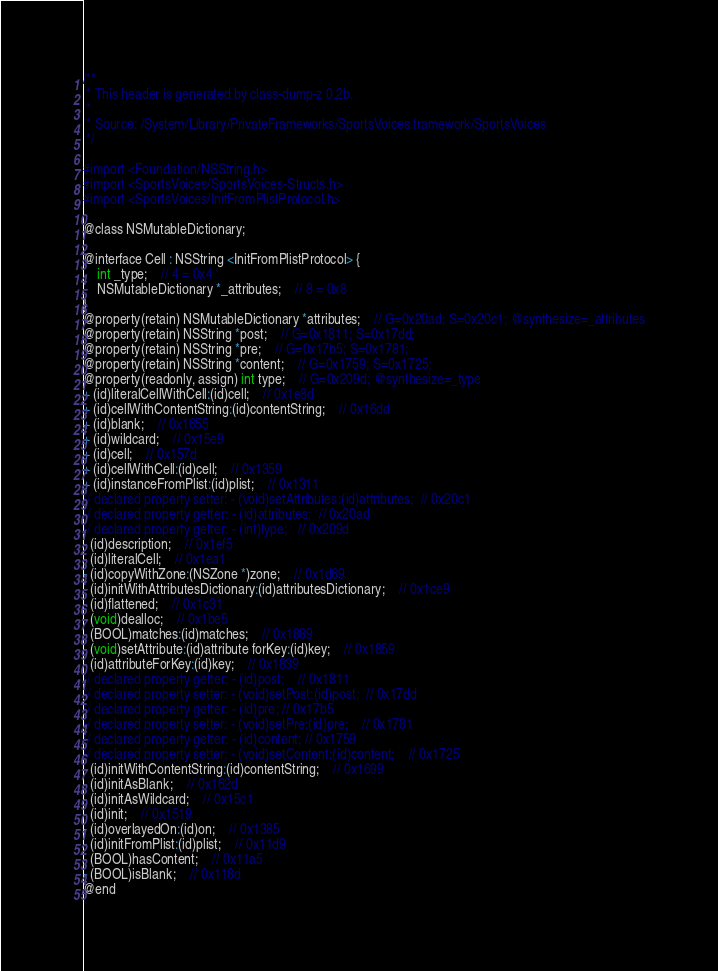Convert code to text. <code><loc_0><loc_0><loc_500><loc_500><_C_>/**
 * This header is generated by class-dump-z 0.2b.
 *
 * Source: /System/Library/PrivateFrameworks/SportsVoices.framework/SportsVoices
 */

#import <Foundation/NSString.h>
#import <SportsVoices/SportsVoices-Structs.h>
#import <SportsVoices/InitFromPlistProtocol.h>

@class NSMutableDictionary;

@interface Cell : NSString <InitFromPlistProtocol> {
	int _type;	// 4 = 0x4
	NSMutableDictionary *_attributes;	// 8 = 0x8
}
@property(retain) NSMutableDictionary *attributes;	// G=0x20ad; S=0x20c1; @synthesize=_attributes
@property(retain) NSString *post;	// G=0x1811; S=0x17dd; 
@property(retain) NSString *pre;	// G=0x17b5; S=0x1781; 
@property(retain) NSString *content;	// G=0x1759; S=0x1725; 
@property(readonly, assign) int type;	// G=0x209d; @synthesize=_type
+ (id)literalCellWithCell:(id)cell;	// 0x1e8d
+ (id)cellWithContentString:(id)contentString;	// 0x16dd
+ (id)blank;	// 0x1655
+ (id)wildcard;	// 0x15e9
+ (id)cell;	// 0x157d
+ (id)cellWithCell:(id)cell;	// 0x1359
+ (id)instanceFromPlist:(id)plist;	// 0x1311
// declared property setter: - (void)setAttributes:(id)attributes;	// 0x20c1
// declared property getter: - (id)attributes;	// 0x20ad
// declared property getter: - (int)type;	// 0x209d
- (id)description;	// 0x1ef5
- (id)literalCell;	// 0x1ea1
- (id)copyWithZone:(NSZone *)zone;	// 0x1d69
- (id)initWithAttributesDictionary:(id)attributesDictionary;	// 0x1ce9
- (id)flattened;	// 0x1c31
- (void)dealloc;	// 0x1be5
- (BOOL)matches:(id)matches;	// 0x1889
- (void)setAttribute:(id)attribute forKey:(id)key;	// 0x1859
- (id)attributeForKey:(id)key;	// 0x1839
// declared property getter: - (id)post;	// 0x1811
// declared property setter: - (void)setPost:(id)post;	// 0x17dd
// declared property getter: - (id)pre;	// 0x17b5
// declared property setter: - (void)setPre:(id)pre;	// 0x1781
// declared property getter: - (id)content;	// 0x1759
// declared property setter: - (void)setContent:(id)content;	// 0x1725
- (id)initWithContentString:(id)contentString;	// 0x1699
- (id)initAsBlank;	// 0x162d
- (id)initAsWildcard;	// 0x15c1
- (id)init;	// 0x1519
- (id)overlayedOn:(id)on;	// 0x1385
- (id)initFromPlist:(id)plist;	// 0x11d9
- (BOOL)hasContent;	// 0x11a5
- (BOOL)isBlank;	// 0x118d
@end
</code> 